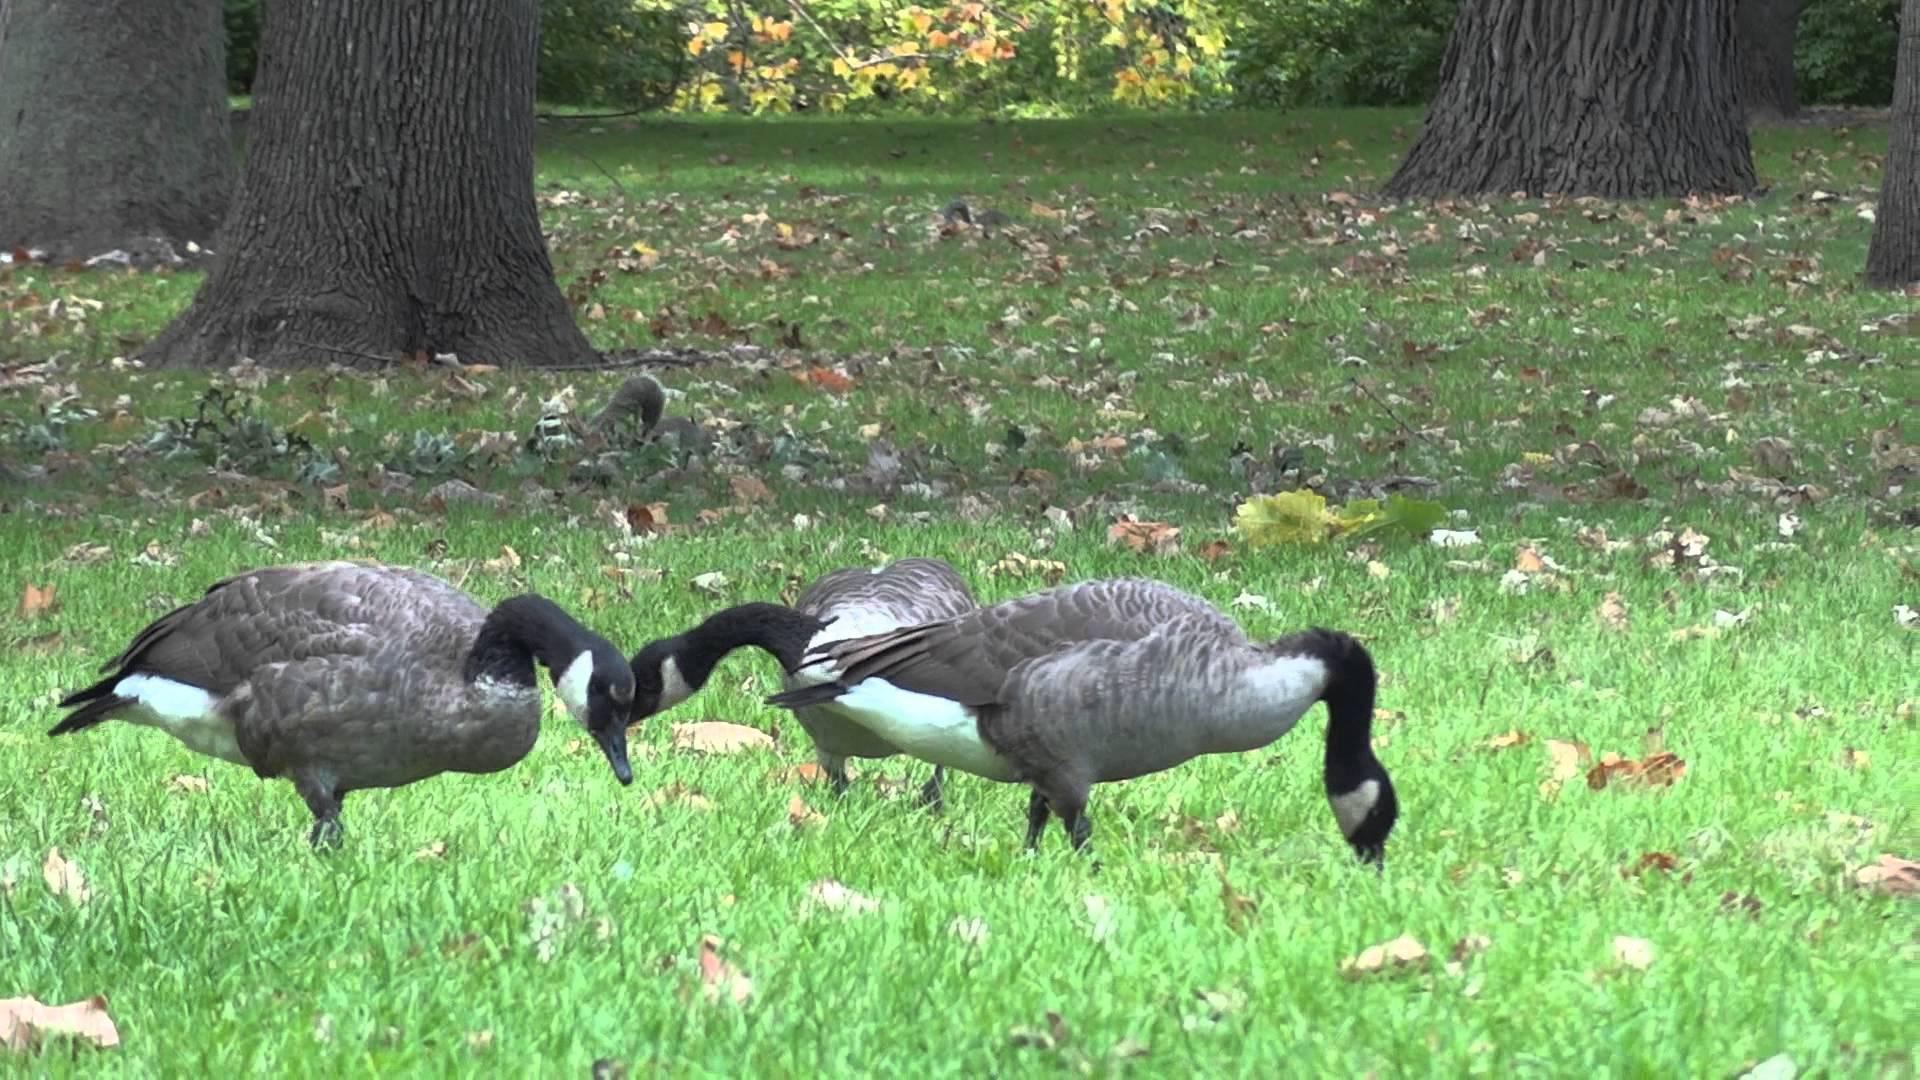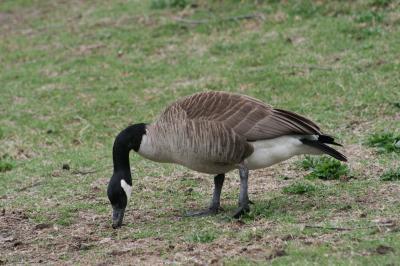The first image is the image on the left, the second image is the image on the right. Examine the images to the left and right. Is the description "There are no more than four birds." accurate? Answer yes or no. Yes. The first image is the image on the left, the second image is the image on the right. Given the left and right images, does the statement "There is an image of a single goose that has its head bent to the ground." hold true? Answer yes or no. Yes. 